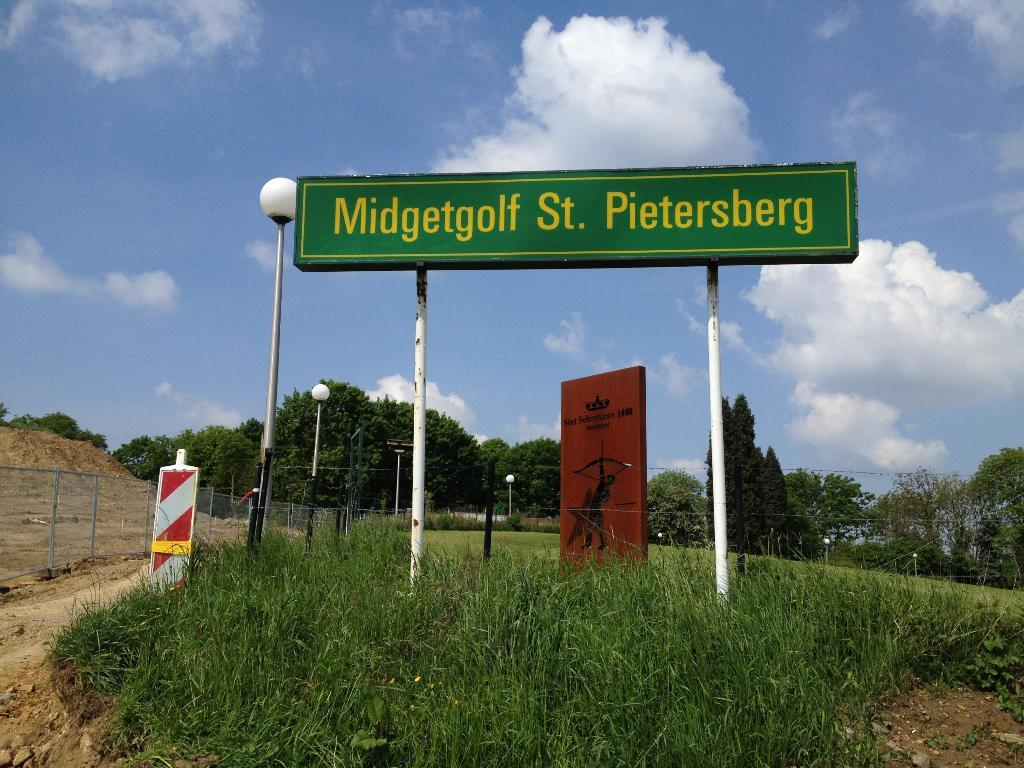<image>
Give a short and clear explanation of the subsequent image. A green sign that says Midgetgolf St. Pietersberg, standing alone in a small patch of grass. 